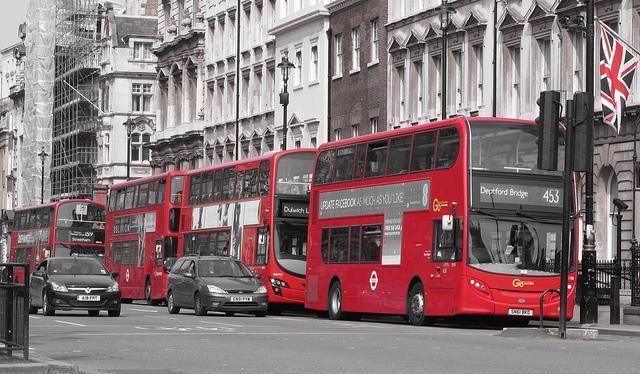How many buses?
Give a very brief answer. 4. How many buses can you see?
Give a very brief answer. 4. How many cars are there?
Give a very brief answer. 2. How many white toilets with brown lids are in this image?
Give a very brief answer. 0. 